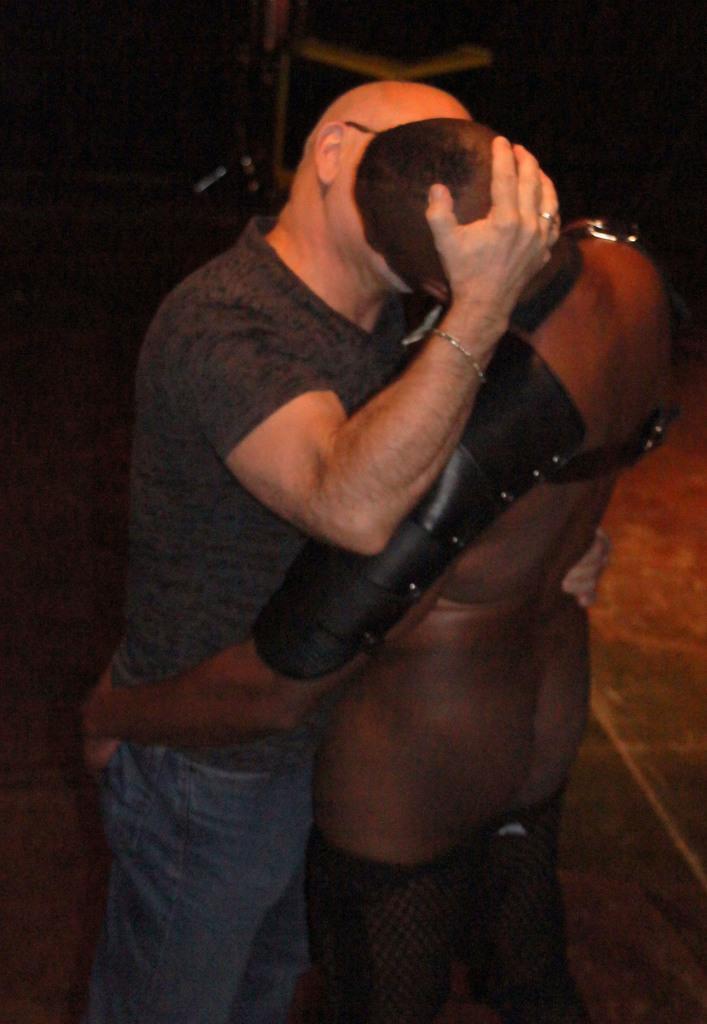How would you summarize this image in a sentence or two? In this image there are two people kissing. 